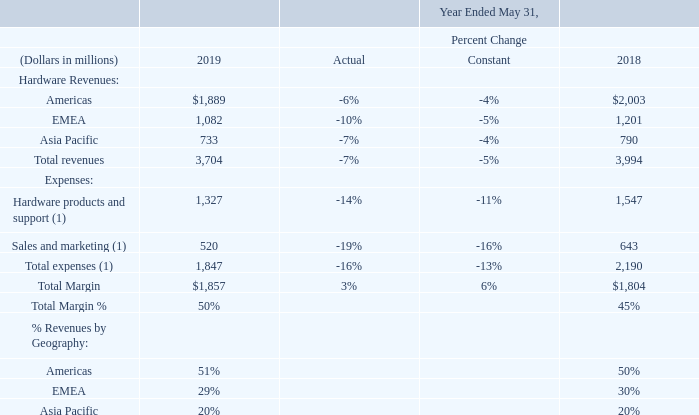Hardware Business
Our hardware business’ revenues are generated from the sales of our Oracle Engineered Systems, server, storage, and industry-specific hardware products. Each hardware product and its related software, such as an operating system or firmware, are highly interdependent and interrelated and are accounted for as a combined performance obligation. The revenues for this combined performance obligation are generally recognized at the point in time that the hardware product and its related software are delivered to the customer and ownership is transferred to the customer. Our hardware business also earns revenues from the sale of hardware support contracts purchased and renewed by our customers at their option and are generally recognized as revenues ratably as the hardware support services are delivered over the contractual term, which is generally one year. The majority of our hardware products are sold through indirect channels such as independent distributors and value-added resellers, and we also market and sell our hardware products through our direct sales force. Operating expenses associated with our hardware business include the cost of hardware products, which consists of expenses for materials and labor used to produce these products by our internal manufacturing operations or by third-party manufacturers, warranty expenses and the impact of periodic changes in inventory valuation, including the impact of inventory determined to be excess and obsolete; the cost of materials used to repair customer products; the cost of labor and infrastructure to provide support services; and sales and marketing expenses, which are largely personnel related and include variable compensation earned by our sales force for the sales of our hardware offerings.
1 ) Excludes stock-based compensation and certain expense allocations. Also excludes amortization of intangible assets and certain other GAAP-based expenses, which were not allocated to our operating segment results for purposes of reporting to and review by our CODMs, as further described under “Presentation of Operating Segments and Other Financial Information” above.
Excluding the effects of currency rate fluctuations, total hardware revenues decreased in fiscal 2019 relative to fiscal 2018 due to lower hardware products revenues and, to a lesser extent, lower hardware support revenues. The decrease in hardware products revenues in fiscal 2019 relative to fiscal 2018 was primarily attributable to our continued emphasis on the marketing and sale of our cloud-based infrastructure technologies, which resulted in reduced sales volumes of certain of our hardware product lines and also impacted the volume of hardware support contracts sold in recent periods. This constant currency hardware revenue decrease was partially offset by certain hardware revenue increases related to our Oracle Engineered Systems offerings, primarily Oracle Exadata.
Excluding the effects of currency rate fluctuations, total hardware expenses decreased in fiscal 2019 compared to fiscal 2018 primarily due to lower hardware products and support costs and lower sales and marketing employee related expenses, all of which aligned to lower hardware revenues.
In constant currency, total margin and total margin as a percentage of revenues for our hardware segment increased in fiscal 2019 due to lower expenses.
How much more hardware revenues came from the Americas as compared to Asia Pacific in 2018? 
Answer scale should be: million. 2,003 - 790
Answer: 1213. What was the sales and marketing expenses in 2019 and 2018?
Answer scale should be: million. 520 + 643 
Answer: 1163. What was the difference in total margin comparing fiscal 2019 and 2018?
Answer scale should be: million. 1,857 - 1,804
Answer: 53. How much was the constant percentage change and the actual percentage change in total margin ?
Answer scale should be: percent. 6%, 3%. What are the components that make up the company's hardware business' revenues? Our hardware business’ revenues are generated from the sales of our oracle engineered systems, server, storage, and industry-specific hardware products. Why did the total hardware expense decrease in fiscal 2019 compared to fiscal 2018? Excluding the effects of currency rate fluctuations, total hardware expenses decreased in fiscal 2019 compared to fiscal 2018 primarily due to lower hardware products and support costs and lower sales and marketing employee related expenses, all of which aligned to lower hardware revenues. 